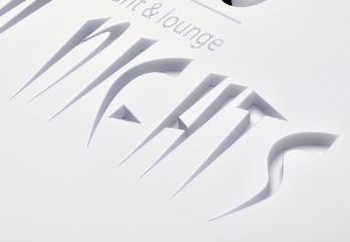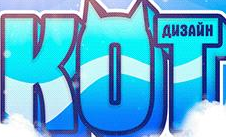Read the text content from these images in order, separated by a semicolon. NIEHTS; KOT 